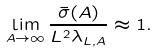<formula> <loc_0><loc_0><loc_500><loc_500>\lim _ { A \to \infty } \frac { \bar { \sigma } ( A ) } { L ^ { 2 } \lambda _ { L , A } } \approx 1 .</formula> 